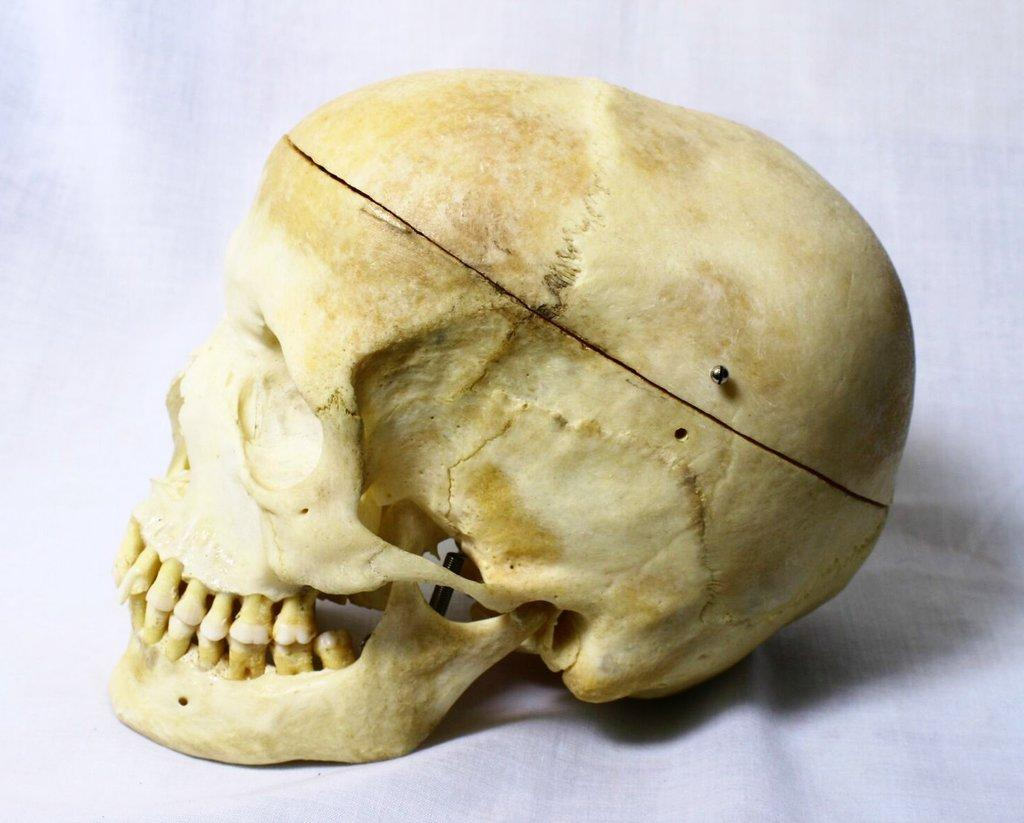What is the main subject of the image? The main subject of the image is a human skull. Can you describe the colors of the skull? The skull is cream, brown, and white in color. What is the color of the background in the image? The background of the image is white. What type of sail can be seen attached to the skull in the image? There is no sail present in the image; it only features a human skull with specific colors. 